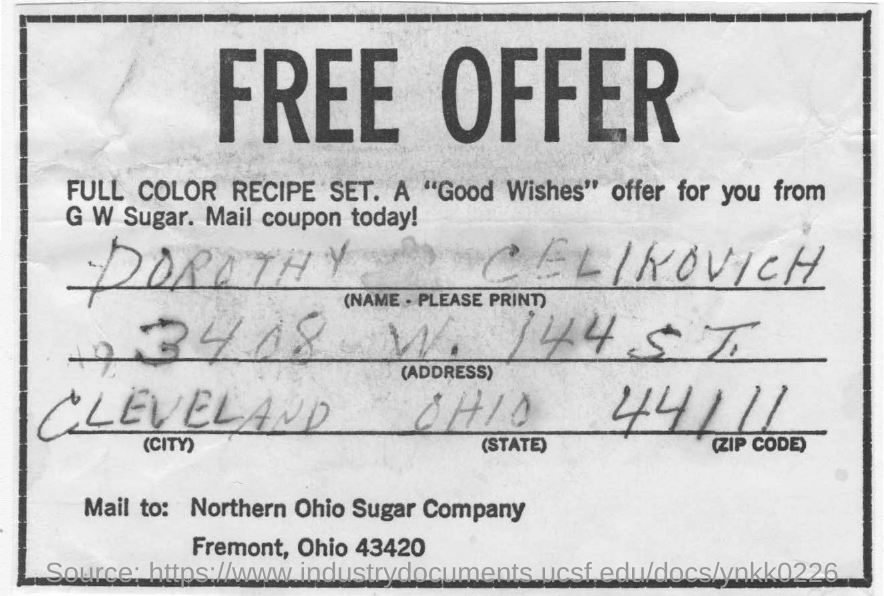What is the "address" written in the form?
Your answer should be compact. 3408 W. 144 ST. What is the ZIP CODE no ?
Give a very brief answer. 44111. What is the name of the person in this document?
Provide a succinct answer. DOROTHY  CELIKOVICH. Which state is mentioned here?
Your answer should be very brief. OHIO. 